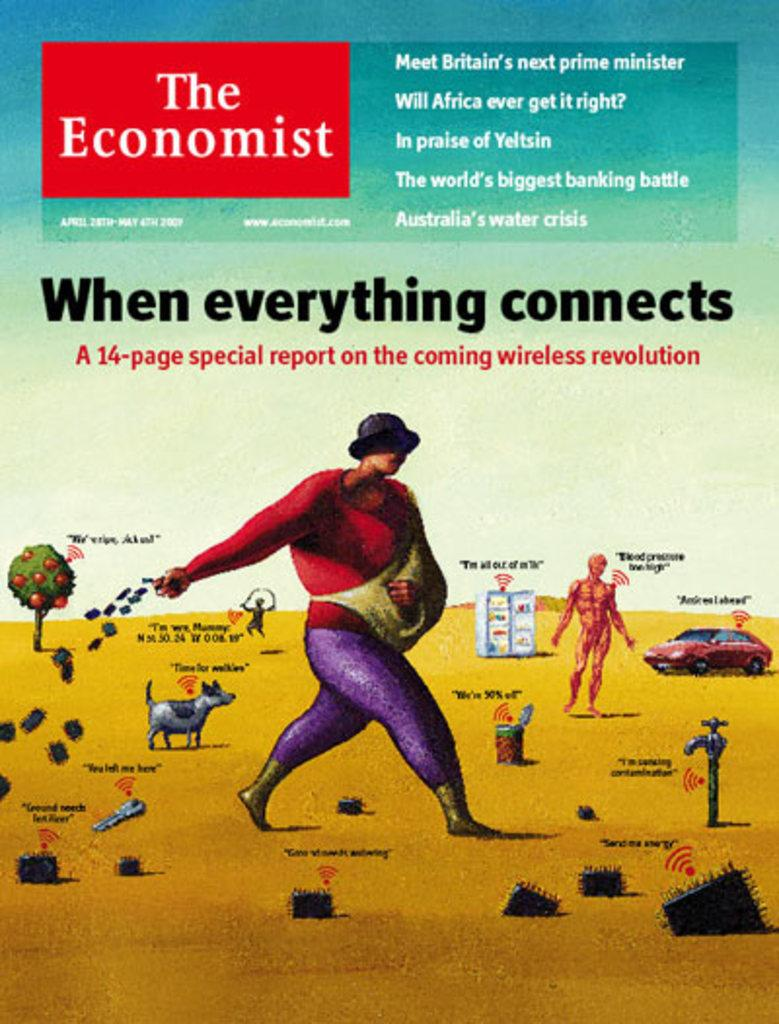<image>
Offer a succinct explanation of the picture presented. The front cover of a 2007 issue of the Economist. 